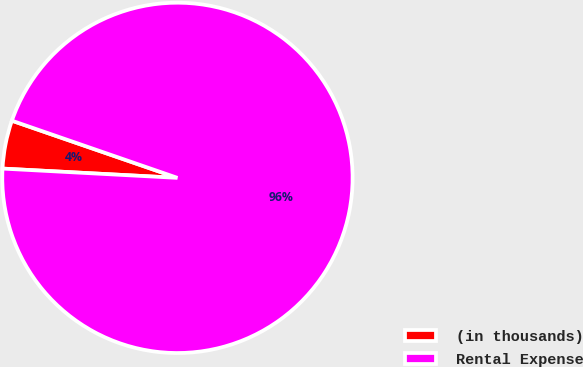Convert chart. <chart><loc_0><loc_0><loc_500><loc_500><pie_chart><fcel>(in thousands)<fcel>Rental Expense<nl><fcel>4.45%<fcel>95.55%<nl></chart> 